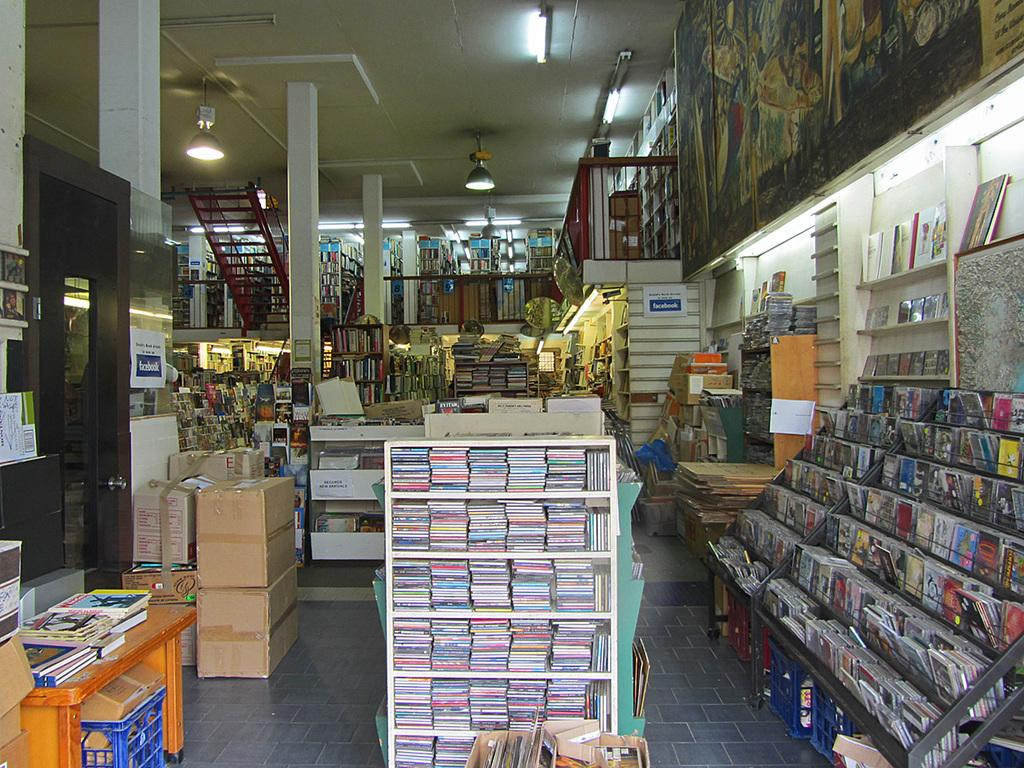What can be seen in the foreground area of the image? In the foreground area of the image, there are books in a rack and shelves with books. What architectural feature is present in the image? There are stairs in the image. What type of lighting is present in the image? There are lamps in the image. What can be seen in the background of the image? In the background of the image, there are other objects and books. What type of glass is being used as bait in the image? There is no glass or bait present in the image; it primarily features books, shelves, stairs, and lamps. 